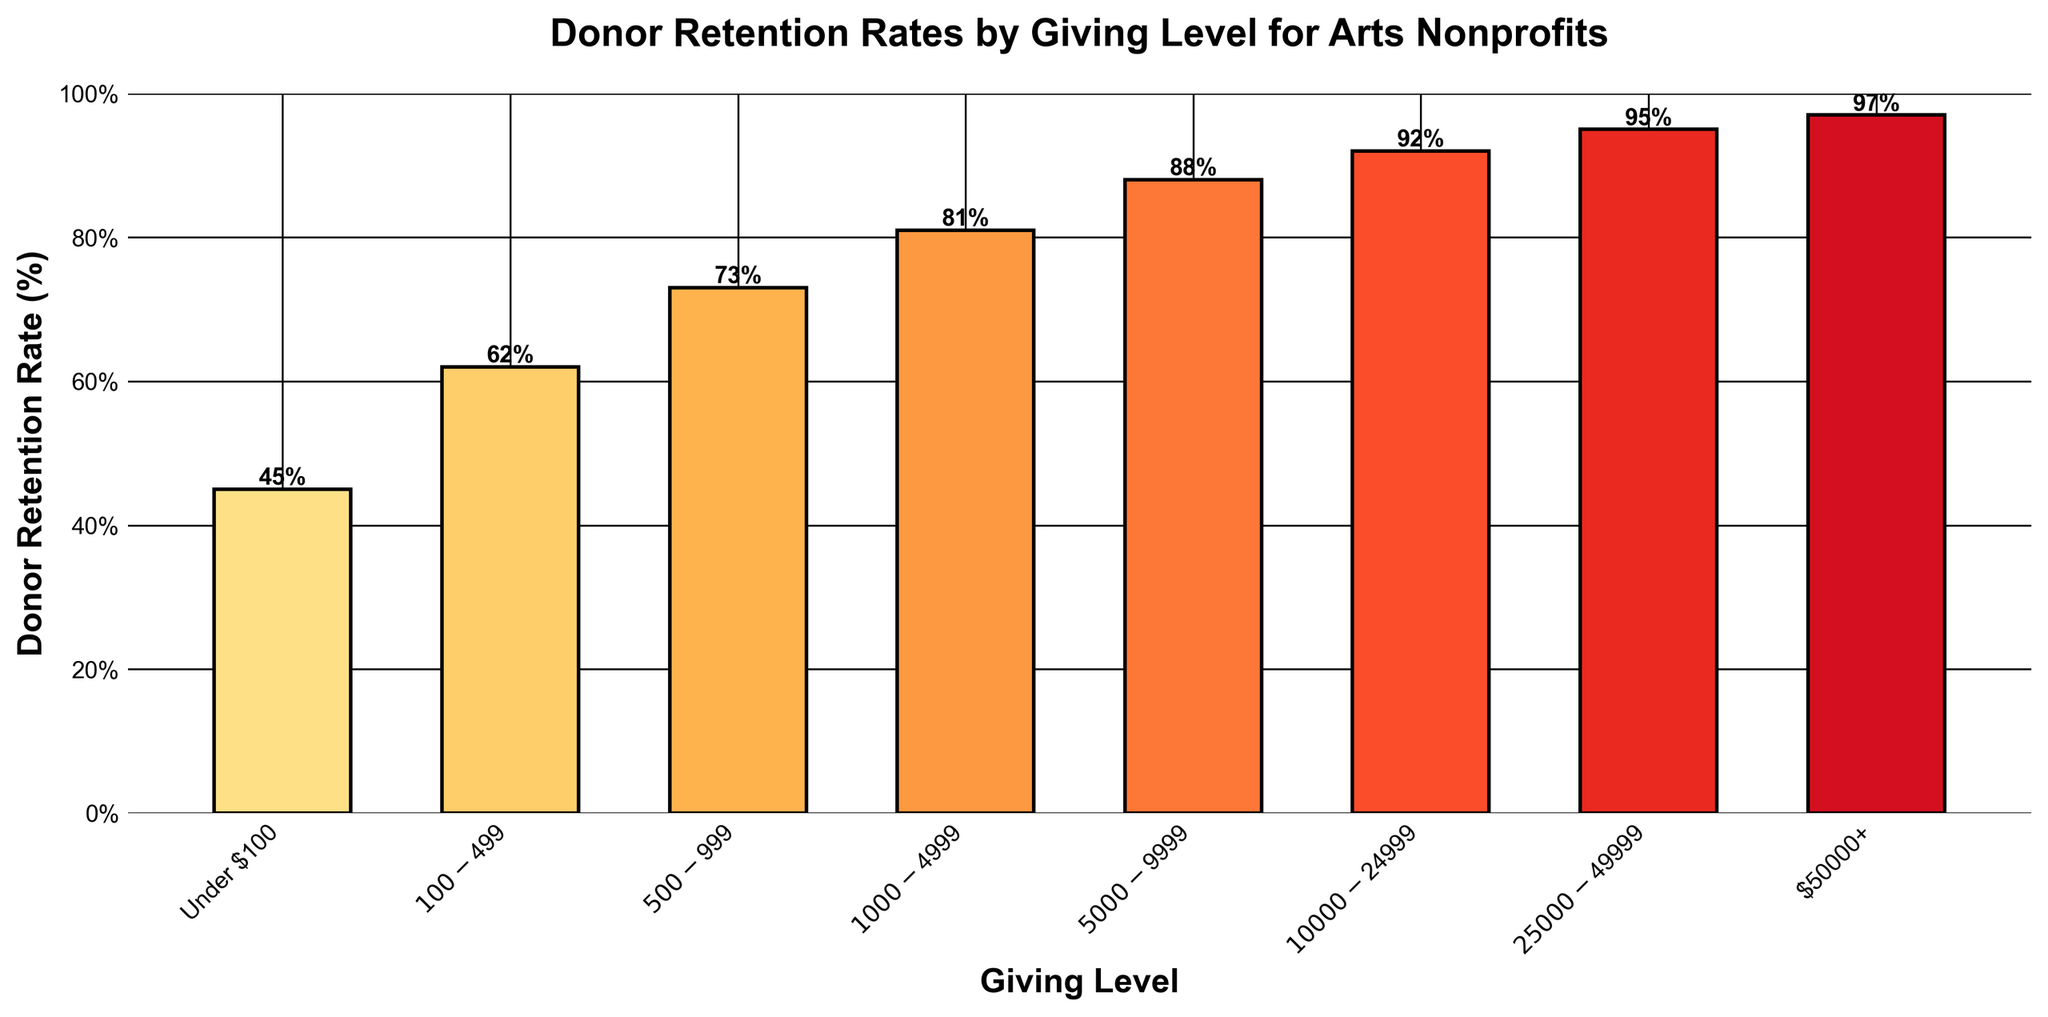Which giving level has the highest donor retention rate? The highest bar on the chart represents the giving level "$50000+", and it's labeled with "97%".
Answer: $50000+ What is the donor retention rate for the $1000-$4999 giving level? Locate the bar for "$1000-$4999" on the x-axis, and observe its height and label, which indicate "81%".
Answer: 81% How much higher is the donor retention rate for the $50000+ level compared to the Under $100 level? The donor retention rate for the $50000+ level is 97%, while for the Under $100 level it is 45%. Subtract 45% from 97%: 97% - 45% = 52%.
Answer: 52% Which giving level has nearly half (around 50%) of the top donor retention rate of $50000+? The top donor retention rate is 97% (for $50000+). Half of 97% is about 48.5%. The closest bar to 48.5% is "Under $100" with 45%.
Answer: Under $100 What is the average retention rate of the first three giving levels (Under $100, $100-$499, $500-$999)? Calculate the average of 45%, 62%, and 73%. (45 + 62 + 73) / 3 = 180 / 3 = 60%.
Answer: 60% Is the donor retention rate for the $10000-$24999 level greater than or less than the $5000-$9999 level? The bar for the $10000-$24999 level shows 92%, while the bar for the $5000-$9999 level shows 88%. 92% is greater than 88%.
Answer: Greater What is the difference in donor retention rates between $100-$499 and $25000-$49999 levels? The donor retention rate for $100-$499 is 62%, and for $25000-$49999 it is 95%. Subtract 62% from 95%: 95% - 62% = 33%.
Answer: 33% What is the visual color gradient pattern used for the bars representing different giving levels? The bars use a gradient from lighter yellow-orange to darker red, becoming more intense as the giving levels increase.
Answer: Gradient from lighter yellow-orange to darker red Which giving level's bar is positioned third from the right on the x-axis, and what is its donor retention rate? The bar third from the right is $10000-$24999, and its donor retention rate is labeled as 92%.
Answer: $10000-$24999, 92% What visual attribute differentiates the highest and lowest giving levels on the chart apart from the bar heights? The highest giving level ($50000+) has a darker bar color and the lowest giving level (Under $100) has a lighter bar color.
Answer: Darker color for $50000+, lighter color for Under $100 